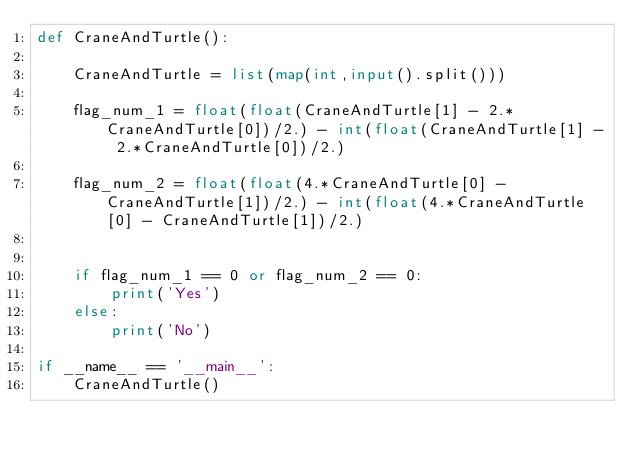Convert code to text. <code><loc_0><loc_0><loc_500><loc_500><_Python_>def CraneAndTurtle():

    CraneAndTurtle = list(map(int,input().split()))

    flag_num_1 = float(float(CraneAndTurtle[1] - 2.*CraneAndTurtle[0])/2.) - int(float(CraneAndTurtle[1] - 2.*CraneAndTurtle[0])/2.)

    flag_num_2 = float(float(4.*CraneAndTurtle[0] - CraneAndTurtle[1])/2.) - int(float(4.*CraneAndTurtle[0] - CraneAndTurtle[1])/2.)


    if flag_num_1 == 0 or flag_num_2 == 0:
        print('Yes')
    else:
        print('No')

if __name__ == '__main__':
    CraneAndTurtle()</code> 